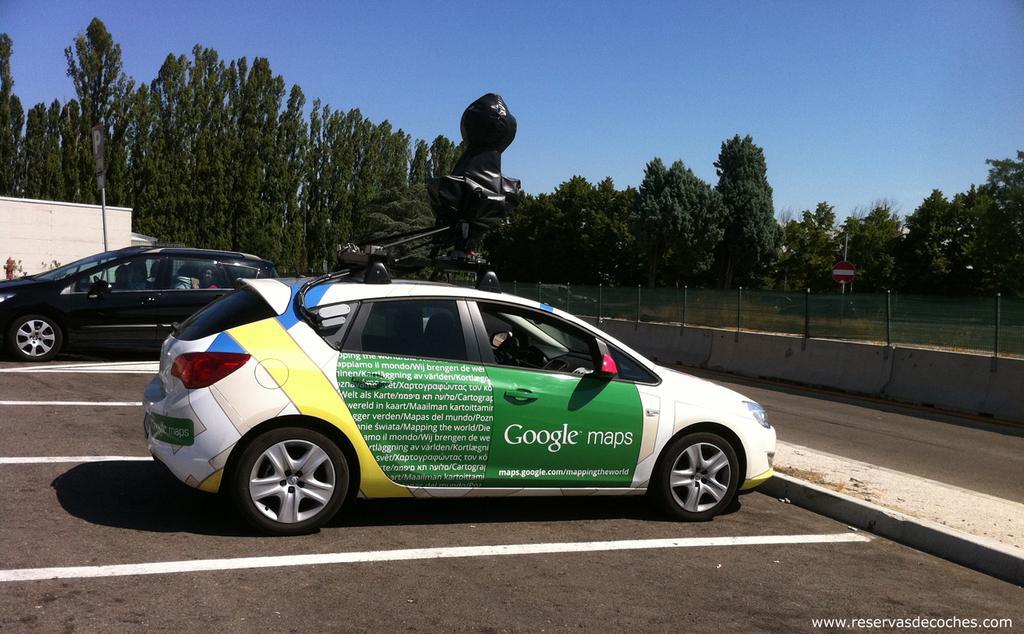Can you describe this image briefly? In this picture we can see there are two vehicles parked on the road and on the car there is an object. On the right side of the vehicles there is a fence, a pole with a board and behind the vehicles there is a house, trees and a sky. 